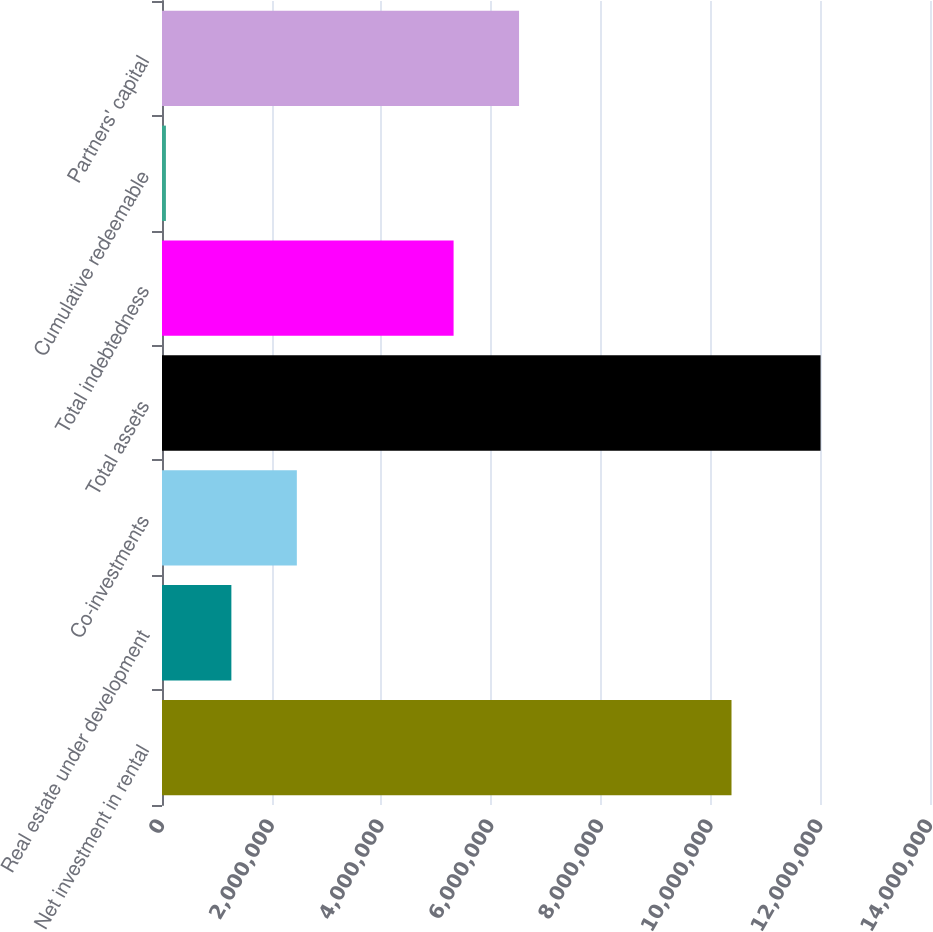Convert chart to OTSL. <chart><loc_0><loc_0><loc_500><loc_500><bar_chart><fcel>Net investment in rental<fcel>Real estate under development<fcel>Co-investments<fcel>Total assets<fcel>Total indebtedness<fcel>Cumulative redeemable<fcel>Partners' capital<nl><fcel>1.03816e+07<fcel>1.2646e+06<fcel>2.45799e+06<fcel>1.20051e+07<fcel>5.31546e+06<fcel>71209<fcel>6.50885e+06<nl></chart> 